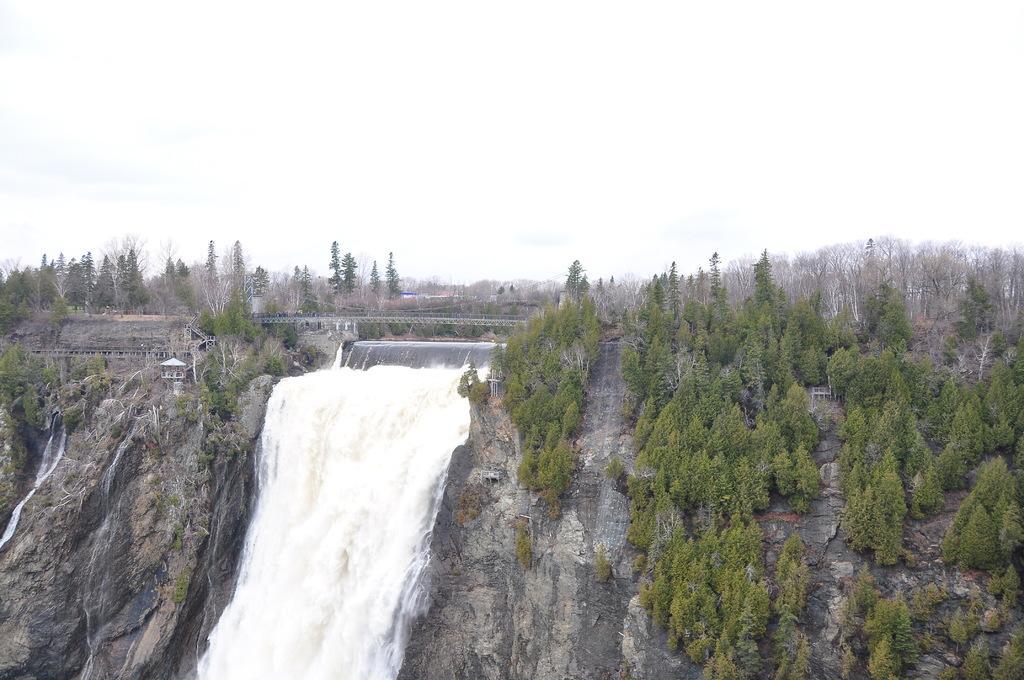Can you describe this image briefly? In this image I can see the water falling from the mountains. In the background there are many trees and the white sky. 